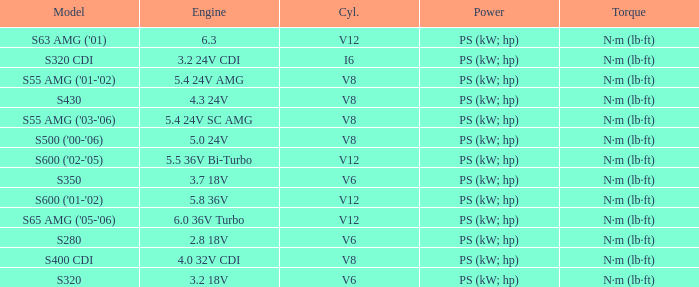Which Engine has a Model of s430? 4.3 24V. 